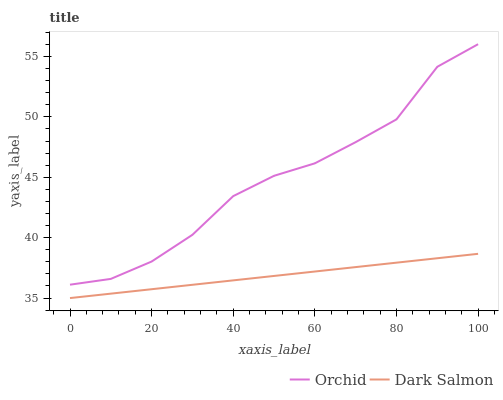Does Dark Salmon have the minimum area under the curve?
Answer yes or no. Yes. Does Orchid have the maximum area under the curve?
Answer yes or no. Yes. Does Orchid have the minimum area under the curve?
Answer yes or no. No. Is Dark Salmon the smoothest?
Answer yes or no. Yes. Is Orchid the roughest?
Answer yes or no. Yes. Is Orchid the smoothest?
Answer yes or no. No. Does Dark Salmon have the lowest value?
Answer yes or no. Yes. Does Orchid have the lowest value?
Answer yes or no. No. Does Orchid have the highest value?
Answer yes or no. Yes. Is Dark Salmon less than Orchid?
Answer yes or no. Yes. Is Orchid greater than Dark Salmon?
Answer yes or no. Yes. Does Dark Salmon intersect Orchid?
Answer yes or no. No. 